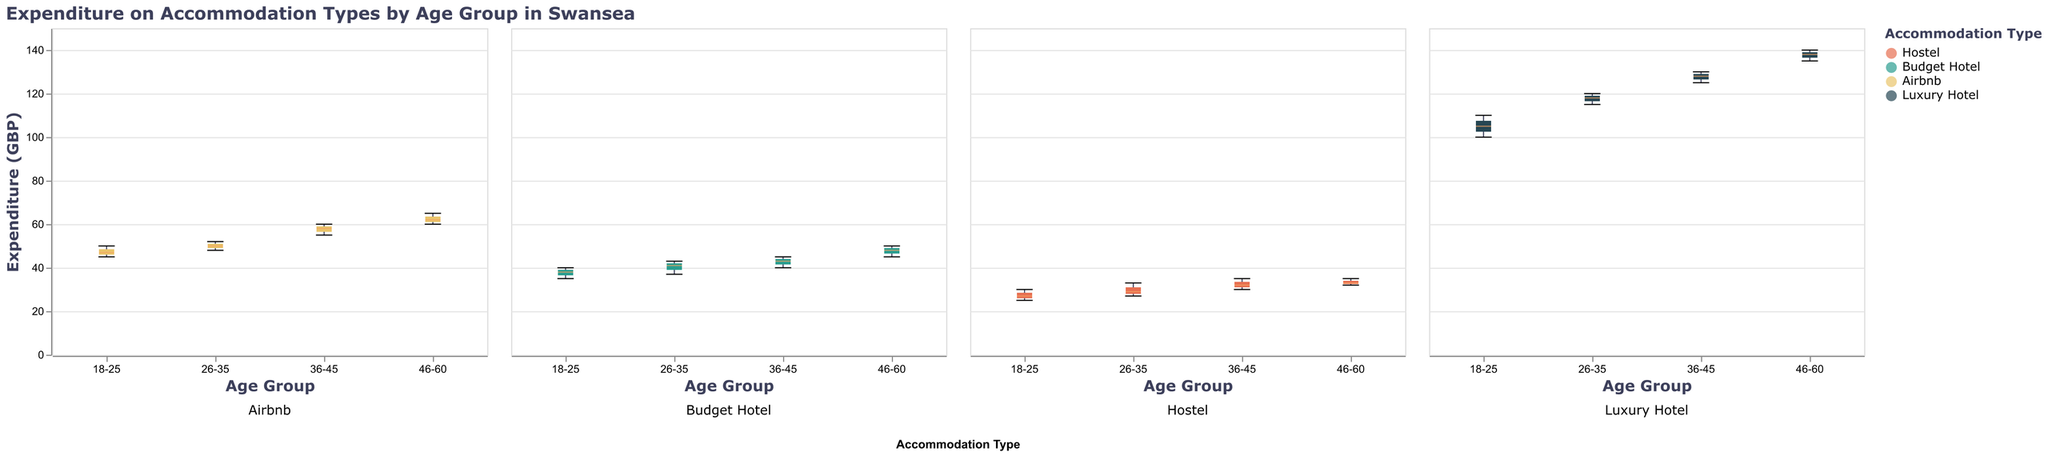What's the title of the figure? The title is written at the top of the figure. It says "Expenditure on Accommodation Types by Age Group in Swansea".
Answer: Expenditure on Accommodation Types by Age Group in Swansea How are the age groups distributed along the x-axis? The age groups are labeled on the x-axis. They are: 18-25, 26-35, 36-45, and 46-60.
Answer: 18-25, 26-35, 36-45, 46-60 Which accommodation type shows the highest expenditure for the 46-60 age group? The box plot for the Luxury Hotel in the 46-60 age group has the highest median value among the given options.
Answer: Luxury Hotel What is the general trend in expenditure as the age group increases? Observing the medians for each accommodation type across age groups, generally, the expenditure increases with age.
Answer: Increases What is the expenditure range for Budget Hotels in the 26-35 age group? The box plot for Budget Hotels in the 26-35 age group gives both the minimum and maximum values. The minimum expenditure is around 37 GBP, and the maximum is about 43 GBP.
Answer: 37 GBP to 43 GBP Compare the median expenditure on Airbnb between the 18-25 age group and the 36-45 age group. The median expenditure on Airbnb for the 18-25 age group is around 47 GBP, while for the 36-45 age group, it is around 58 GBP.
Answer: 58 GBP is higher Which age group spends the most on Hostels? By looking at the box plots for Hostels across different age groups, the 46-60 age group has the highest median expenditure.
Answer: 46-60 How does the variability in expenditure for Luxury Hotels compare across age groups? The spread of the box plots and the length of the whiskers provide information on variability. The variability increases with age groups, and it's highest for the 46-60 age group.
Answer: Increases with age Which accommodation type has the least variability in expenditure for the 18-25 age group? The shortest box plot with the smallest range indicates the least variability. For the 18-25 age group, it's the Hostel.
Answer: Hostel What is the average median expenditure across all accommodation types for the 36-45 age group? First, obtain the median values for each accommodation type in the 36-45 age group (Hostel: ~32 GBP, Budget Hotel: ~43 GBP, Airbnb: ~58 GBP, Luxury Hotel: ~128 GBP). Then, sum these values and divide by the number of accommodation types: (32 + 43 + 58 + 128) / 4 = 65.25 GBP.
Answer: 65.25 GBP 